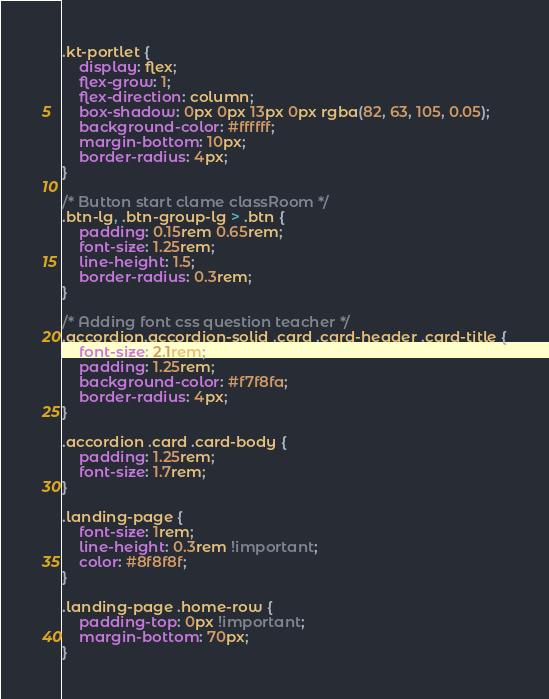Convert code to text. <code><loc_0><loc_0><loc_500><loc_500><_CSS_>
.kt-portlet {
    display: flex;
    flex-grow: 1;
    flex-direction: column;
    box-shadow: 0px 0px 13px 0px rgba(82, 63, 105, 0.05);
    background-color: #ffffff;
    margin-bottom: 10px;
    border-radius: 4px;
}

/* Button start clame classRoom */
.btn-lg, .btn-group-lg > .btn {
    padding: 0.15rem 0.65rem;
    font-size: 1.25rem;
    line-height: 1.5;
    border-radius: 0.3rem;
}

/* Adding font css question teacher */
.accordion.accordion-solid .card .card-header .card-title {
    font-size: 2.1rem;
    padding: 1.25rem;
    background-color: #f7f8fa;
    border-radius: 4px;
}

.accordion .card .card-body {
    padding: 1.25rem;
    font-size: 1.7rem;
}

.landing-page {
    font-size: 1rem;
    line-height: 0.3rem !important;
    color: #8f8f8f;
}

.landing-page .home-row {
    padding-top: 0px !important;
    margin-bottom: 70px;
}
</code> 